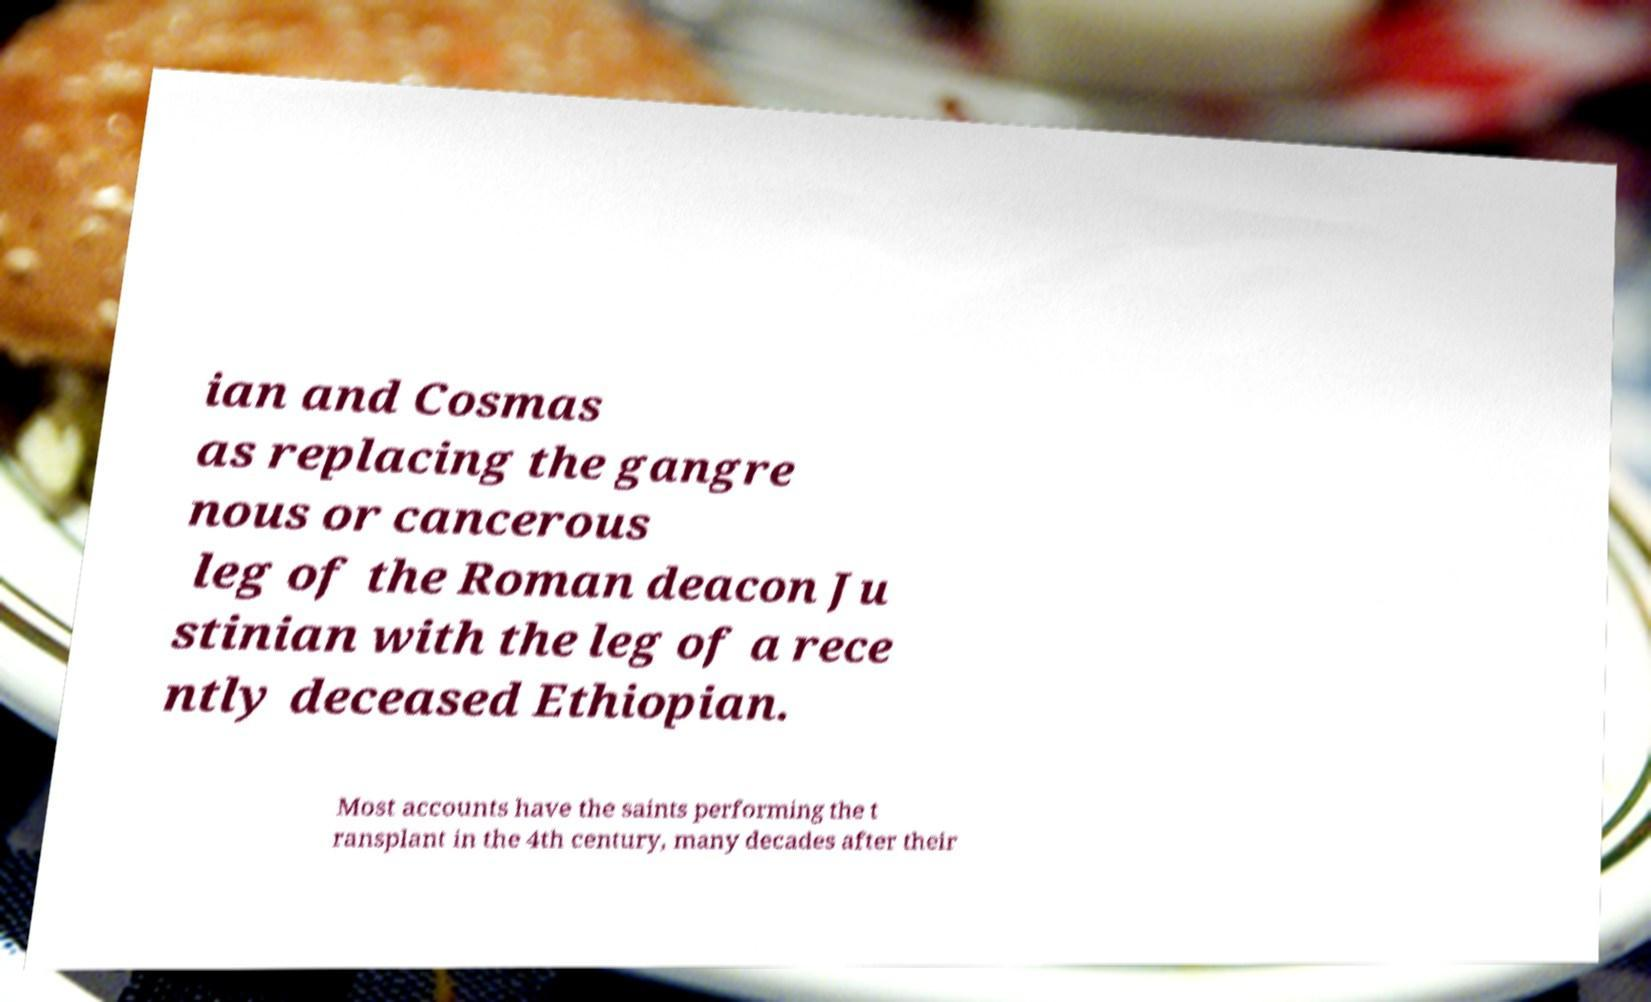Please identify and transcribe the text found in this image. ian and Cosmas as replacing the gangre nous or cancerous leg of the Roman deacon Ju stinian with the leg of a rece ntly deceased Ethiopian. Most accounts have the saints performing the t ransplant in the 4th century, many decades after their 